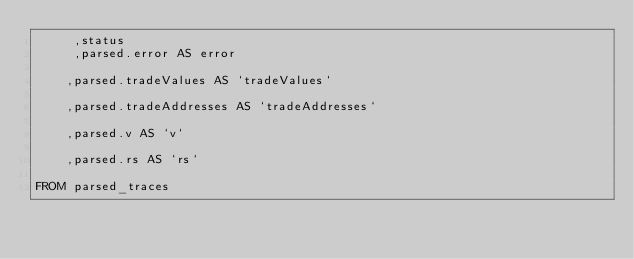<code> <loc_0><loc_0><loc_500><loc_500><_SQL_>     ,status
     ,parsed.error AS error

    ,parsed.tradeValues AS `tradeValues`

    ,parsed.tradeAddresses AS `tradeAddresses`

    ,parsed.v AS `v`

    ,parsed.rs AS `rs`

FROM parsed_traces</code> 